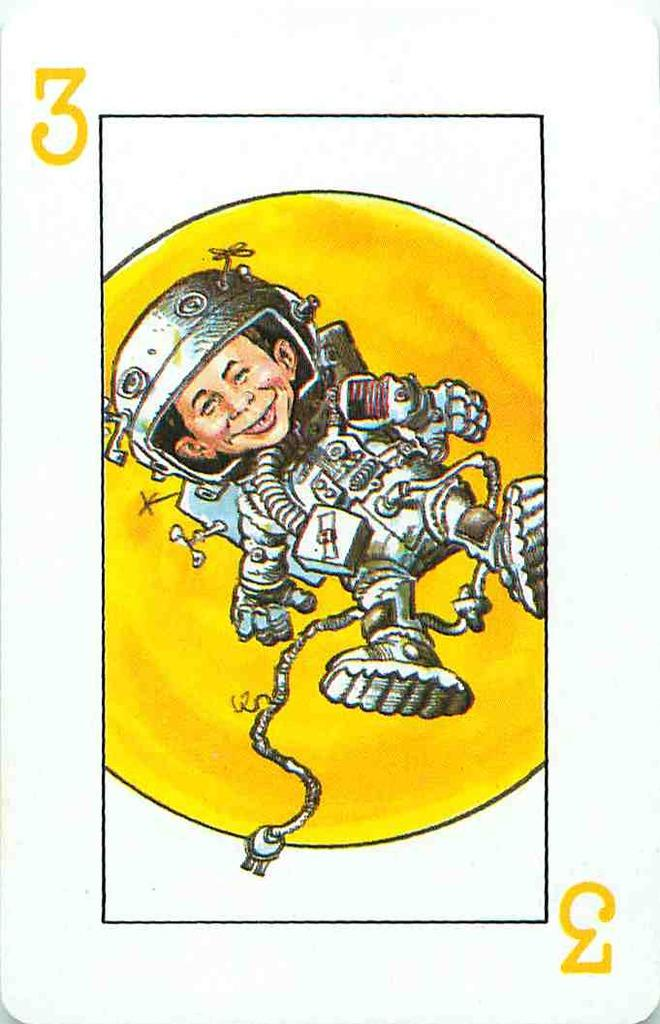What is the color of the playing card in the image? The playing card in the image is white. What is depicted on the playing card? There is a cartoon type boy on the playing card. What is the boy wearing? The boy is wearing an astronaut suit. What color is the background behind the boy? The background behind the boy is yellow. What caption is written on the canvas in the image? There is no canvas or caption present in the image; it features a white playing card with a cartoon boy wearing an astronaut suit on a yellow background. 